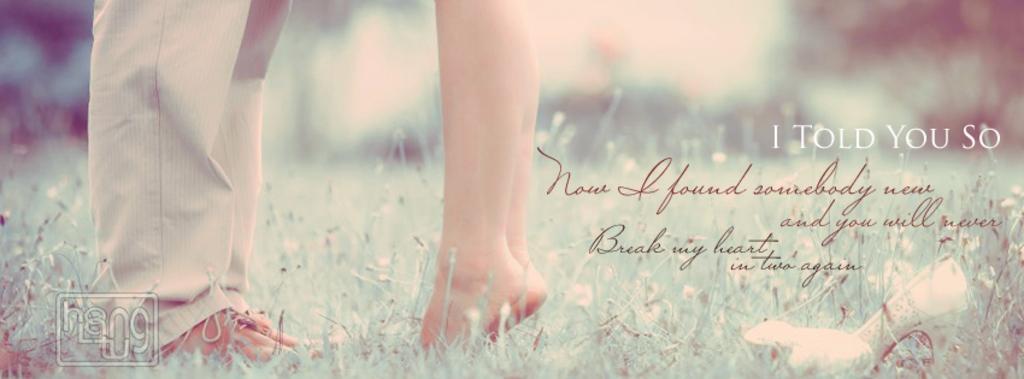Can you describe this image briefly? In this image we can see a poster, in the poster we can see persons legs, grass and some text. 